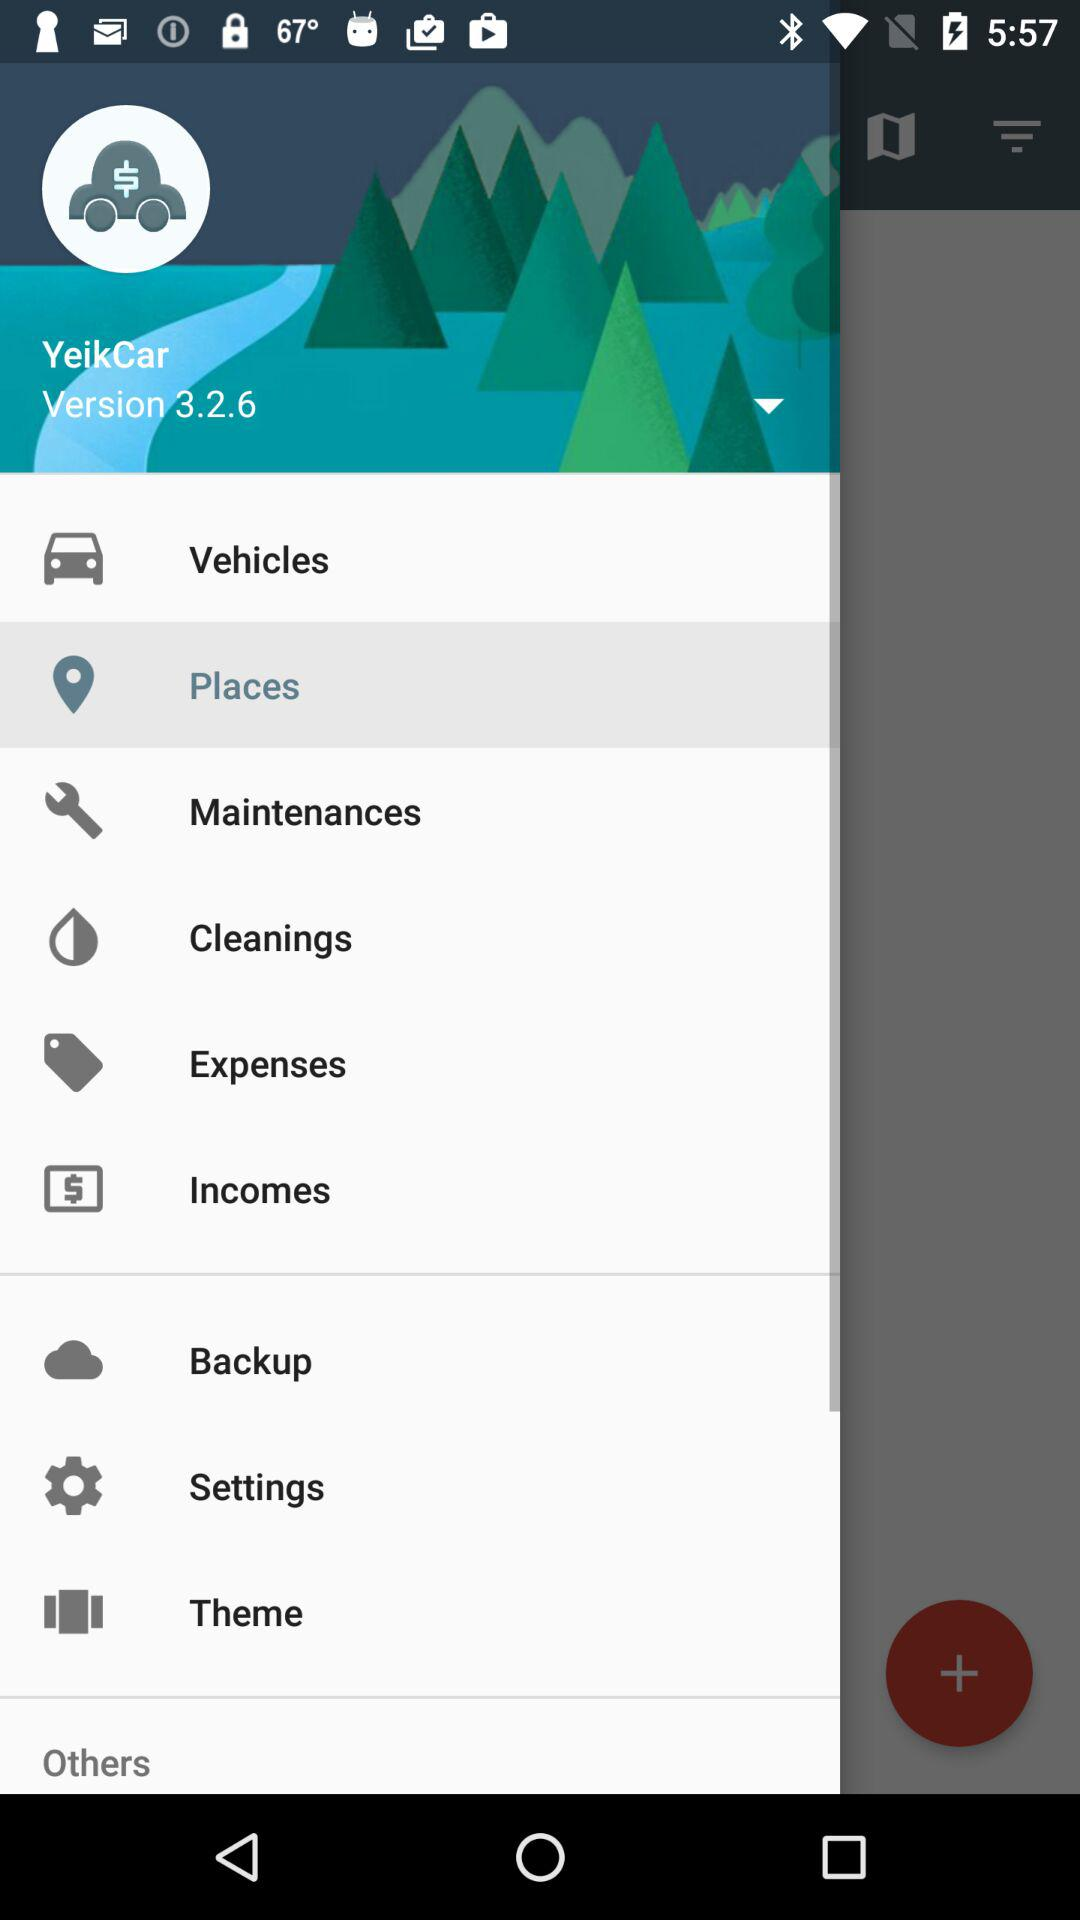What is the application name? The application name is "YeikCar". 